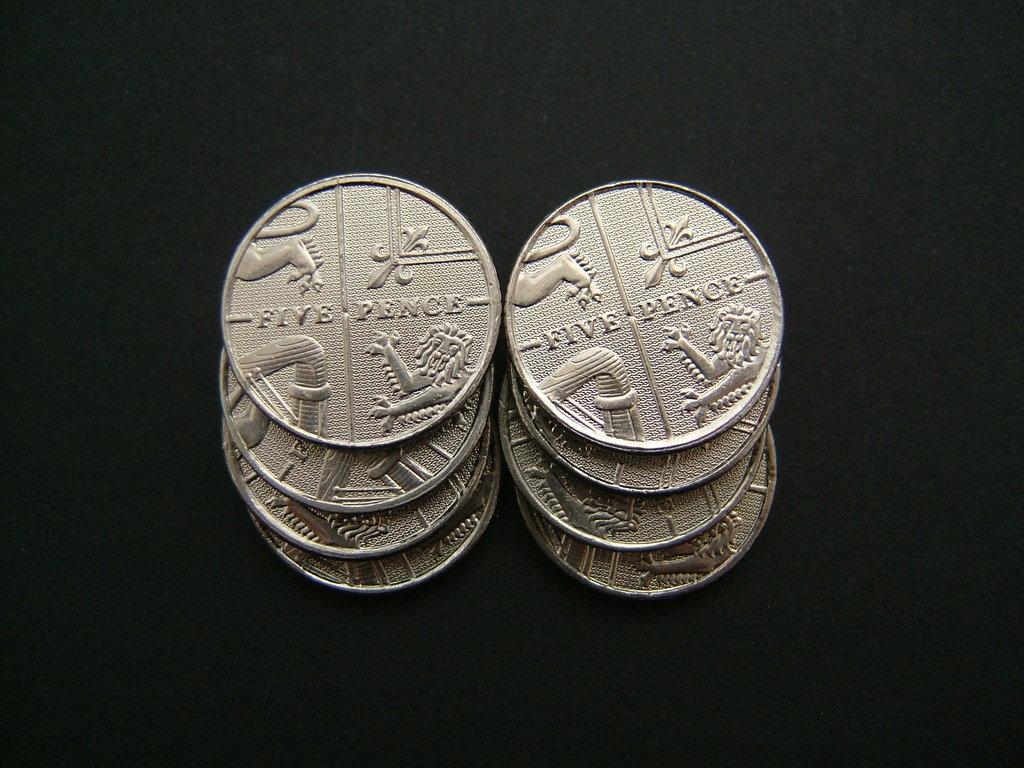How many pence is this?
Your answer should be very brief. Five. How much money is this?
Your answer should be compact. Five pence. 